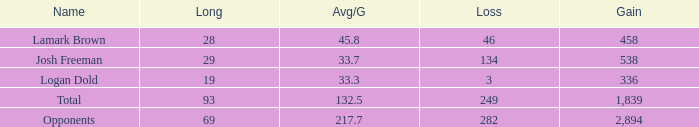Which Avg/G has a Long of 93, and a Loss smaller than 249? None. 